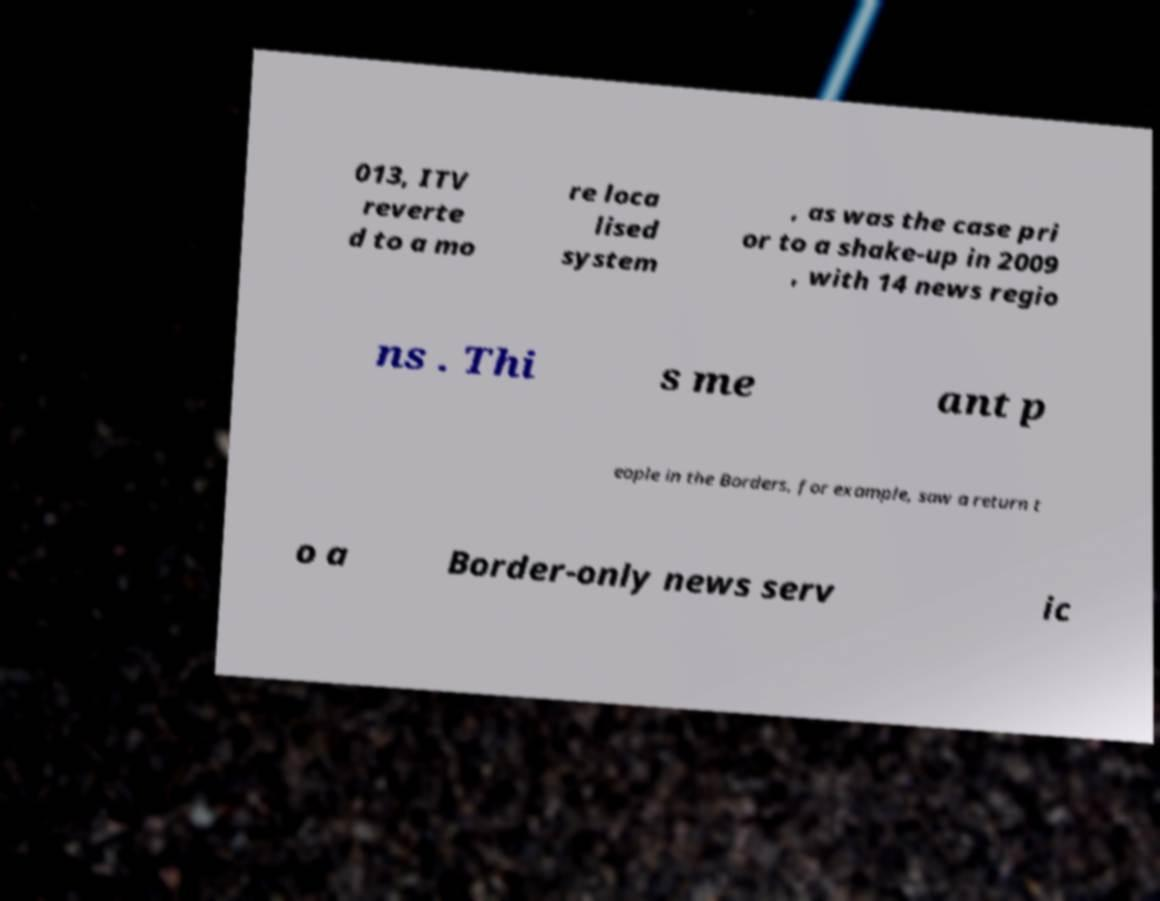Could you extract and type out the text from this image? 013, ITV reverte d to a mo re loca lised system , as was the case pri or to a shake-up in 2009 , with 14 news regio ns . Thi s me ant p eople in the Borders, for example, saw a return t o a Border-only news serv ic 